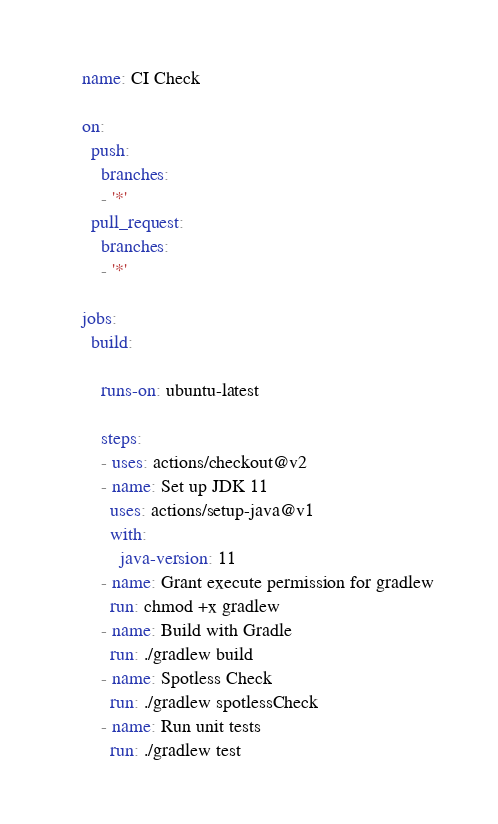Convert code to text. <code><loc_0><loc_0><loc_500><loc_500><_YAML_>name: CI Check

on:
  push:
    branches:
    - '*'
  pull_request:
    branches:
    - '*'

jobs:
  build:

    runs-on: ubuntu-latest

    steps:
    - uses: actions/checkout@v2
    - name: Set up JDK 11
      uses: actions/setup-java@v1
      with:
        java-version: 11
    - name: Grant execute permission for gradlew
      run: chmod +x gradlew
    - name: Build with Gradle
      run: ./gradlew build
    - name: Spotless Check
      run: ./gradlew spotlessCheck
    - name: Run unit tests
      run: ./gradlew test
</code> 